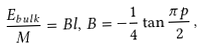<formula> <loc_0><loc_0><loc_500><loc_500>\frac { E _ { b u l k } } { M } = B l , \, B = - \frac { 1 } { 4 } \tan \frac { \pi p } { 2 } \, ,</formula> 